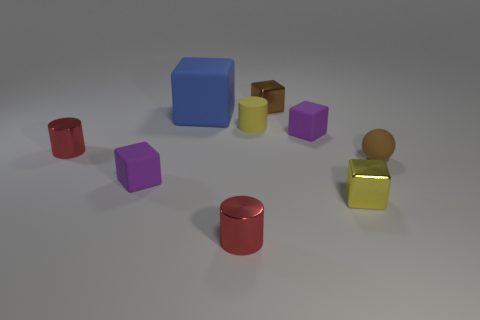There is another brown object that is the same material as the big thing; what is its shape?
Provide a succinct answer. Sphere. Is the number of yellow cylinders that are behind the small brown metallic thing less than the number of big blocks in front of the small yellow cylinder?
Your response must be concise. No. What number of big objects are either yellow cylinders or shiny balls?
Your response must be concise. 0. Does the matte object in front of the rubber ball have the same shape as the big blue object that is behind the yellow matte cylinder?
Your response must be concise. Yes. How big is the matte cube right of the red metal thing in front of the small shiny block in front of the tiny rubber cylinder?
Offer a terse response. Small. There is a purple matte thing that is on the left side of the small yellow cylinder; how big is it?
Your answer should be compact. Small. What is the material of the small purple thing that is right of the tiny yellow rubber thing?
Ensure brevity in your answer.  Rubber. How many gray objects are matte objects or blocks?
Ensure brevity in your answer.  0. Are the blue block and the tiny purple cube that is right of the large blue object made of the same material?
Ensure brevity in your answer.  Yes. Are there an equal number of small cylinders in front of the blue rubber block and yellow cubes left of the tiny yellow cylinder?
Ensure brevity in your answer.  No. 